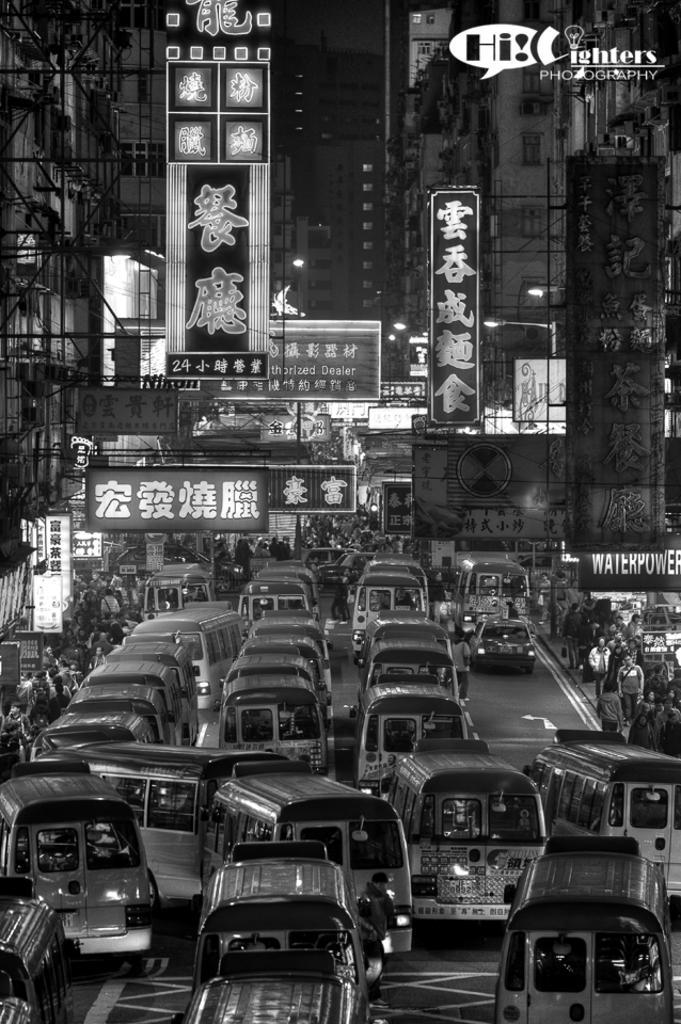Describe this image in one or two sentences. In this image we can see black and white picture of a group of cars parked on the road. In the background, we can see a group of people standing on the ground, buildings with sign boards and text, a group of lights. 